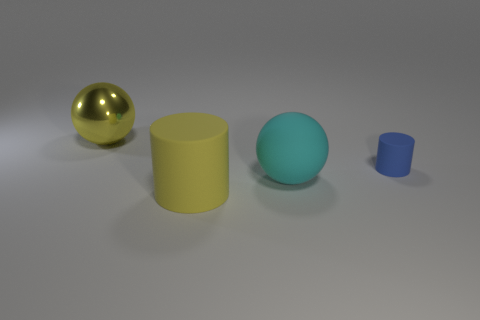Add 1 blue matte cylinders. How many objects exist? 5 Subtract 0 purple balls. How many objects are left? 4 Subtract all big cylinders. Subtract all small blue cylinders. How many objects are left? 2 Add 3 cyan spheres. How many cyan spheres are left? 4 Add 3 tiny rubber things. How many tiny rubber things exist? 4 